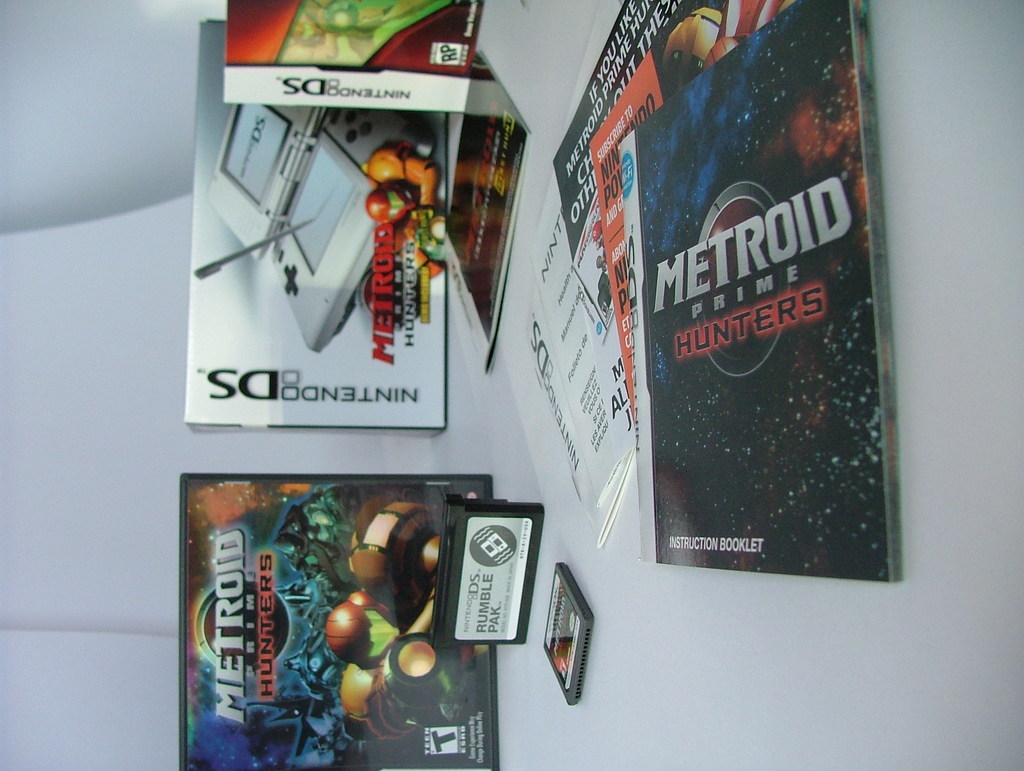<image>
Offer a succinct explanation of the picture presented. A box for Nintendo DS next to the Metroid Prime Hunters game case with the pamphlet for the game in the foreground 